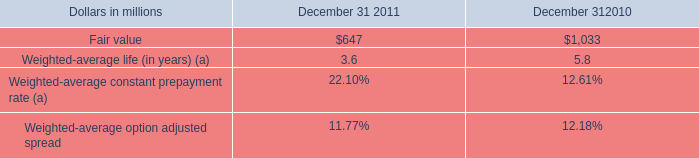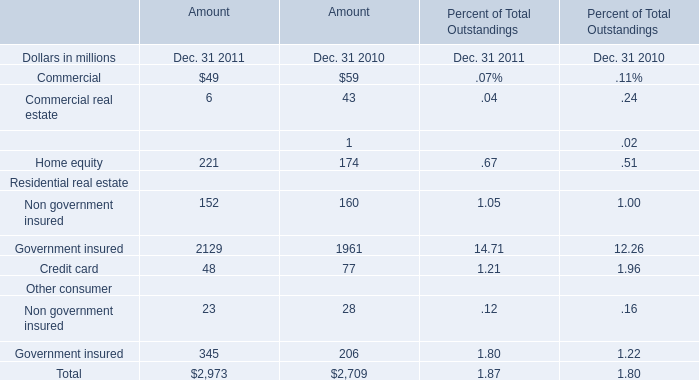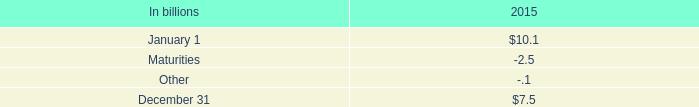by what percentage did the fair value decrease from 2010 to 2011? 
Computations: (((1033 - 647) / 1033) * 100)
Answer: 37.36689. 